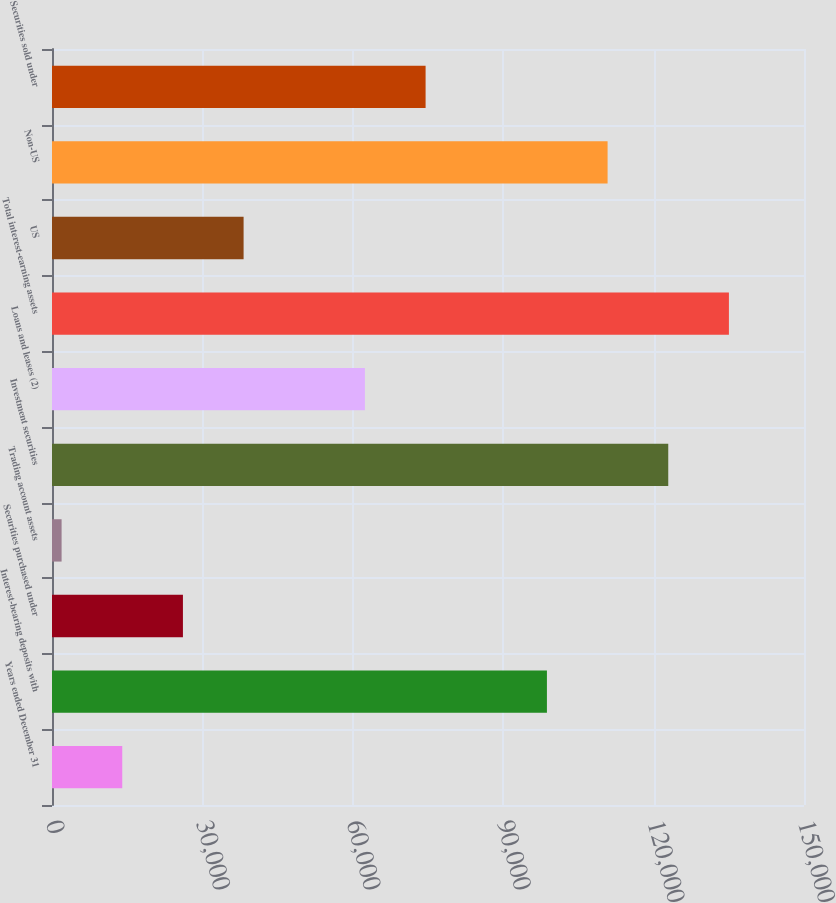Convert chart to OTSL. <chart><loc_0><loc_0><loc_500><loc_500><bar_chart><fcel>Years ended December 31<fcel>Interest-bearing deposits with<fcel>Securities purchased under<fcel>Trading account assets<fcel>Investment securities<fcel>Loans and leases (2)<fcel>Total interest-earning assets<fcel>US<fcel>Non-US<fcel>Securities sold under<nl><fcel>14014.9<fcel>98721.2<fcel>26115.8<fcel>1914<fcel>122923<fcel>62418.5<fcel>135024<fcel>38216.7<fcel>110822<fcel>74519.4<nl></chart> 